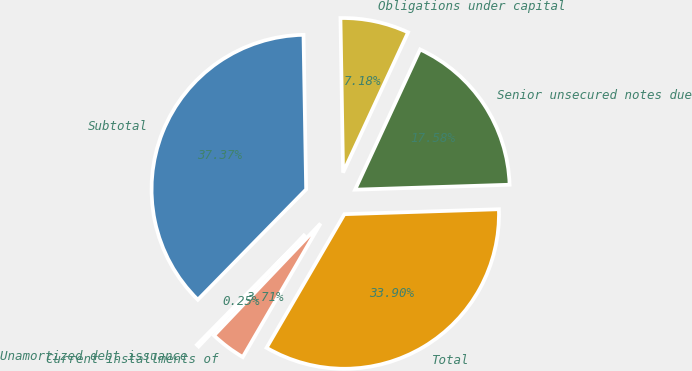<chart> <loc_0><loc_0><loc_500><loc_500><pie_chart><fcel>Senior unsecured notes due<fcel>Obligations under capital<fcel>Subtotal<fcel>Unamortized debt issuance<fcel>Current installments of<fcel>Total<nl><fcel>17.58%<fcel>7.18%<fcel>37.37%<fcel>0.25%<fcel>3.71%<fcel>33.9%<nl></chart> 